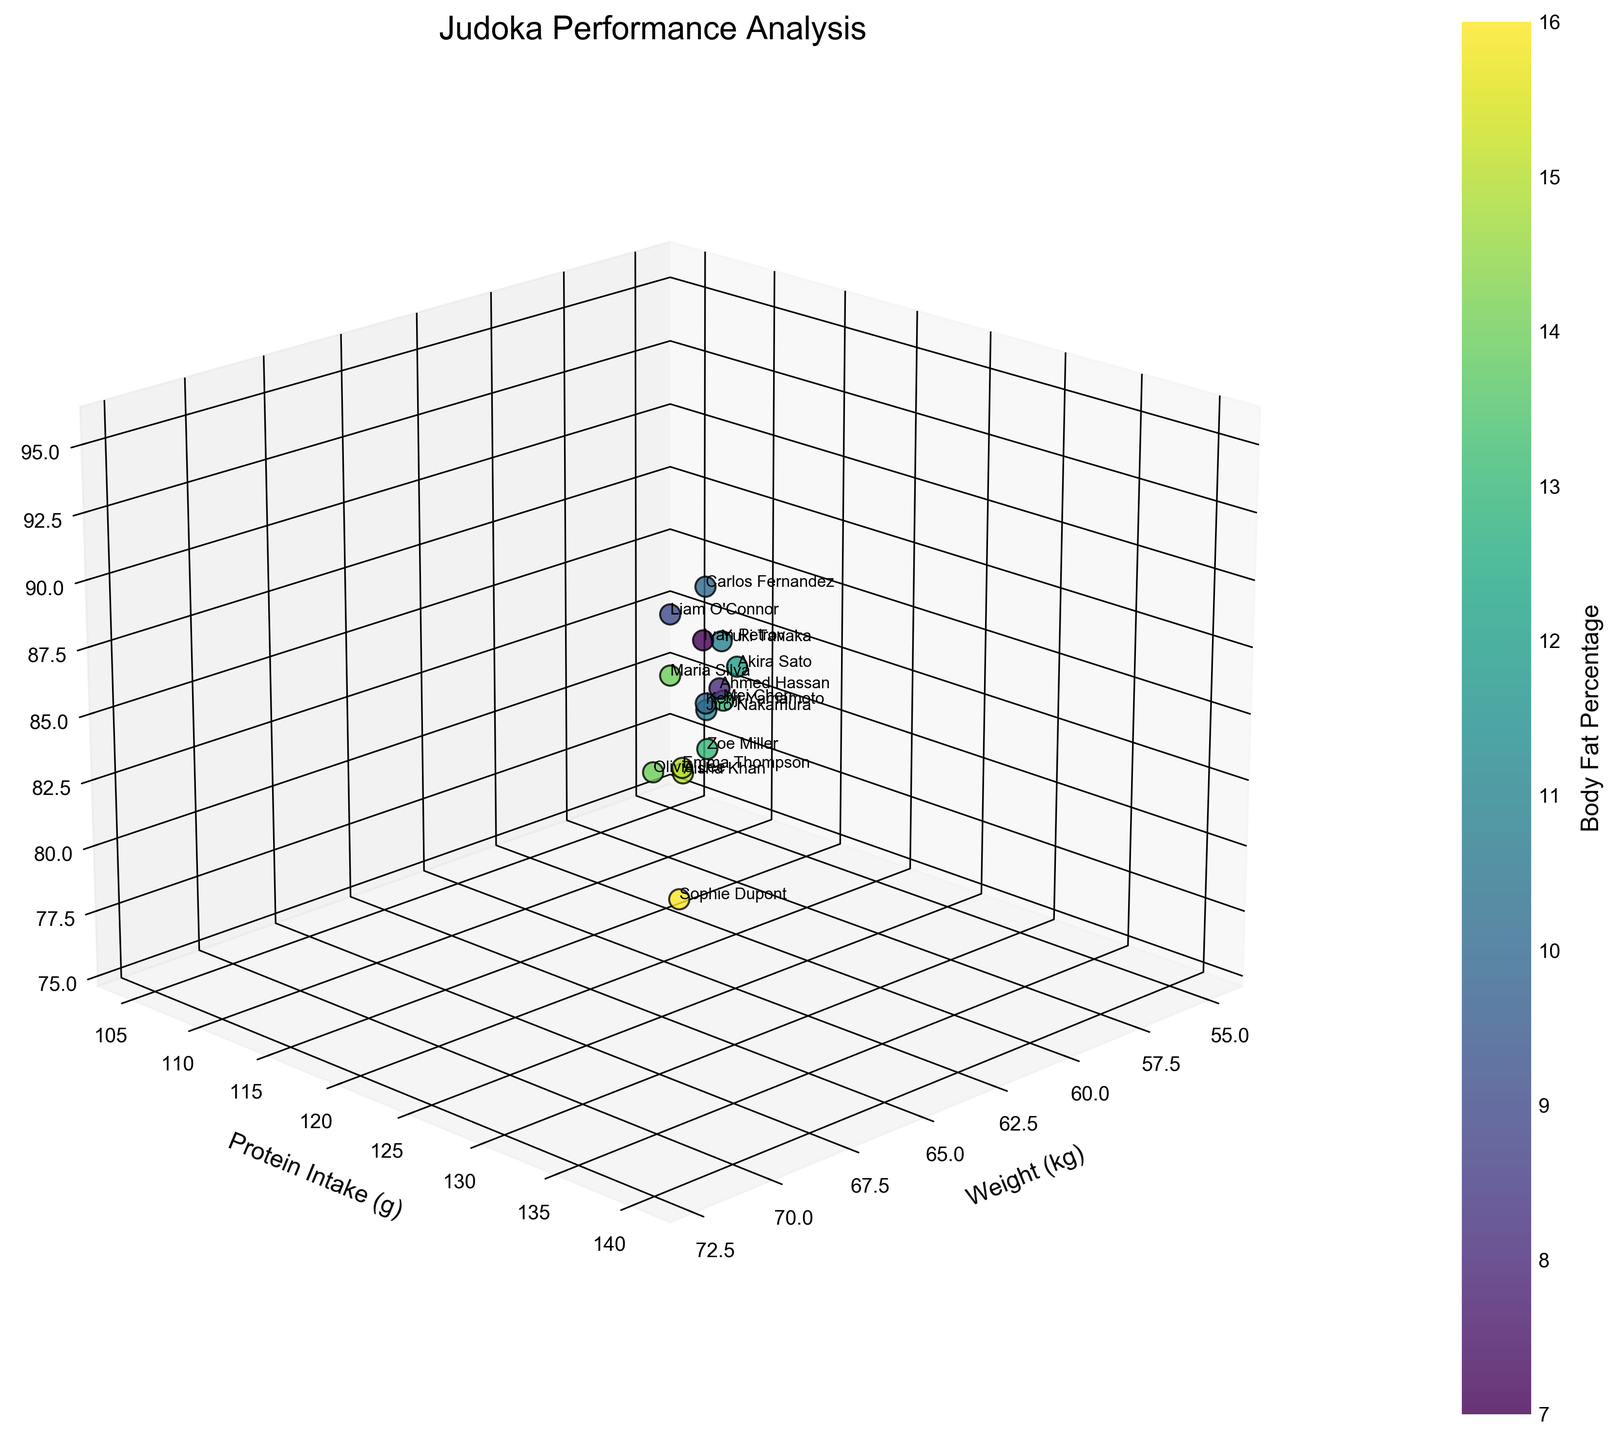What is the title of the figure? The title of the figure is written at the top and is the largest text in the plot. It reads "Judoka Performance Analysis."
Answer: Judoka Performance Analysis How many data points are visible in the plot? Each data point corresponds to a judoka, and there are 15 names annotated on the plot. Count the number of judokas to get the total number of data points.
Answer: 15 Which judoka has the highest body fat percentage? The body fat percentages are represented by the color bar on the side, with darker colors indicating higher percentages. Evaluate from the scatter plot who is at the darkest color. Sophie Dupont has the highest body fat percentage at 16%.
Answer: Sophie Dupont What is the body fat percentage for Ivan Petrov? Locate Ivan Petrov's data point on the graph, observe the corresponding color, and check it against the color bar legend. Ivan Petrov's data matches with a body fat percentage of 7%.
Answer: 7% Compare the performances of Carlos Fernandez and Olivia Lee. Who has a higher performance score? Identify the points for Carlos Fernandez and Olivia Lee in the 3D space and compare their performance scores on the Z-axis. Carlos Fernandez has a performance score of 92, which is higher than Olivia Lee's score of 79.
Answer: Carlos Fernandez What is the average protein intake for Mei Chen and Ahmed Hassan? Read the protein intake values from the y-axis for Mei Chen (115 g) and Ahmed Hassan (135 g). Calculate the average: (115 + 135) / 2 = 125 g.
Answer: 125 g What is the relationship between weight and protein intake for Liam O'Connor? Look up Liam O'Connor's data point, then check his weight on the x-axis and protein intake on the y-axis. Liam O'Connor weighs 72 kg and has a protein intake of 140 g.
Answer: 72 kg, 140 g Which judoka has the closest performance score to Zoe Miller? Identify Zoe Miller's performance score (83) on the Z-axis and then find the closest value to this score among other judokas. Mei Chen has a performance score of 82, which is closest to Zoe Miller's score.
Answer: Mei Chen Do any judokas have the same protein intake? Compare the individual protein intake values on the y-axis to identify identical values. There are no duplicate protein intake values in the dataset provided.
Answer: No 